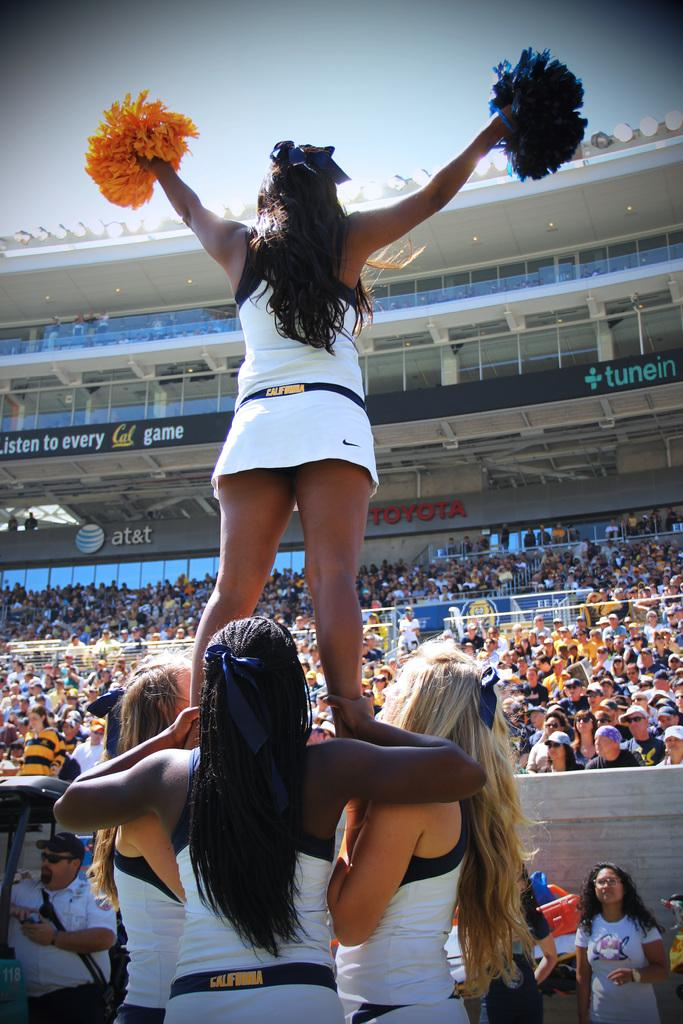<image>
Render a clear and concise summary of the photo. Cheerleaders from a California team are performing for a crowd. 